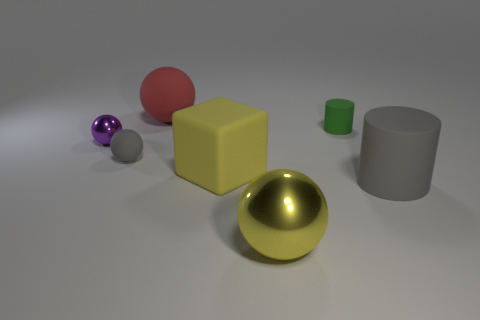Subtract all large yellow spheres. How many spheres are left? 3 Subtract 2 spheres. How many spheres are left? 2 Subtract all cubes. How many objects are left? 6 Add 4 tiny metallic objects. How many tiny metallic objects are left? 5 Add 1 metal things. How many metal things exist? 3 Add 2 matte spheres. How many objects exist? 9 Subtract all red balls. How many balls are left? 3 Subtract 1 yellow spheres. How many objects are left? 6 Subtract all cyan cylinders. Subtract all green blocks. How many cylinders are left? 2 Subtract all cyan spheres. How many green cylinders are left? 1 